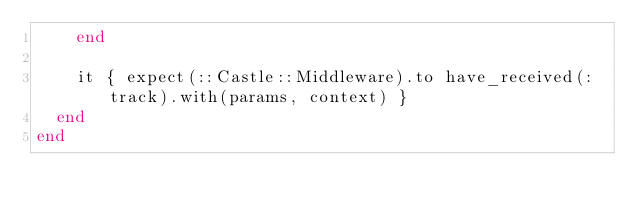Convert code to text. <code><loc_0><loc_0><loc_500><loc_500><_Ruby_>    end

    it { expect(::Castle::Middleware).to have_received(:track).with(params, context) }
  end
end
</code> 